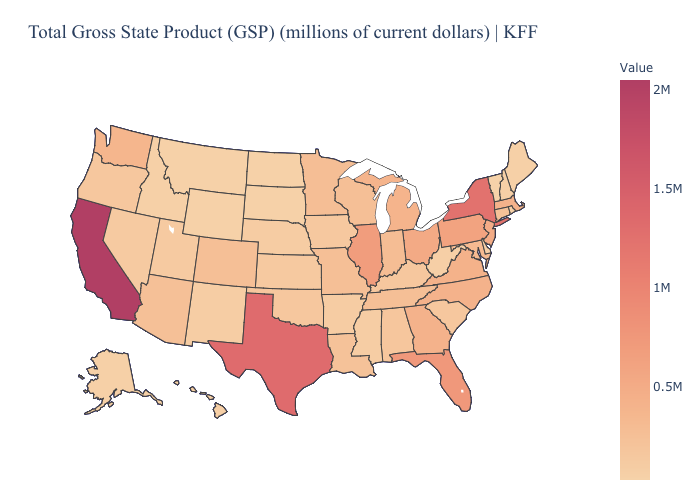Does the map have missing data?
Answer briefly. No. Does Illinois have the highest value in the MidWest?
Be succinct. Yes. Among the states that border Colorado , does Kansas have the highest value?
Short answer required. No. Which states have the lowest value in the Northeast?
Answer briefly. Vermont. Does Illinois have the highest value in the MidWest?
Give a very brief answer. Yes. Which states have the lowest value in the West?
Quick response, please. Wyoming. 